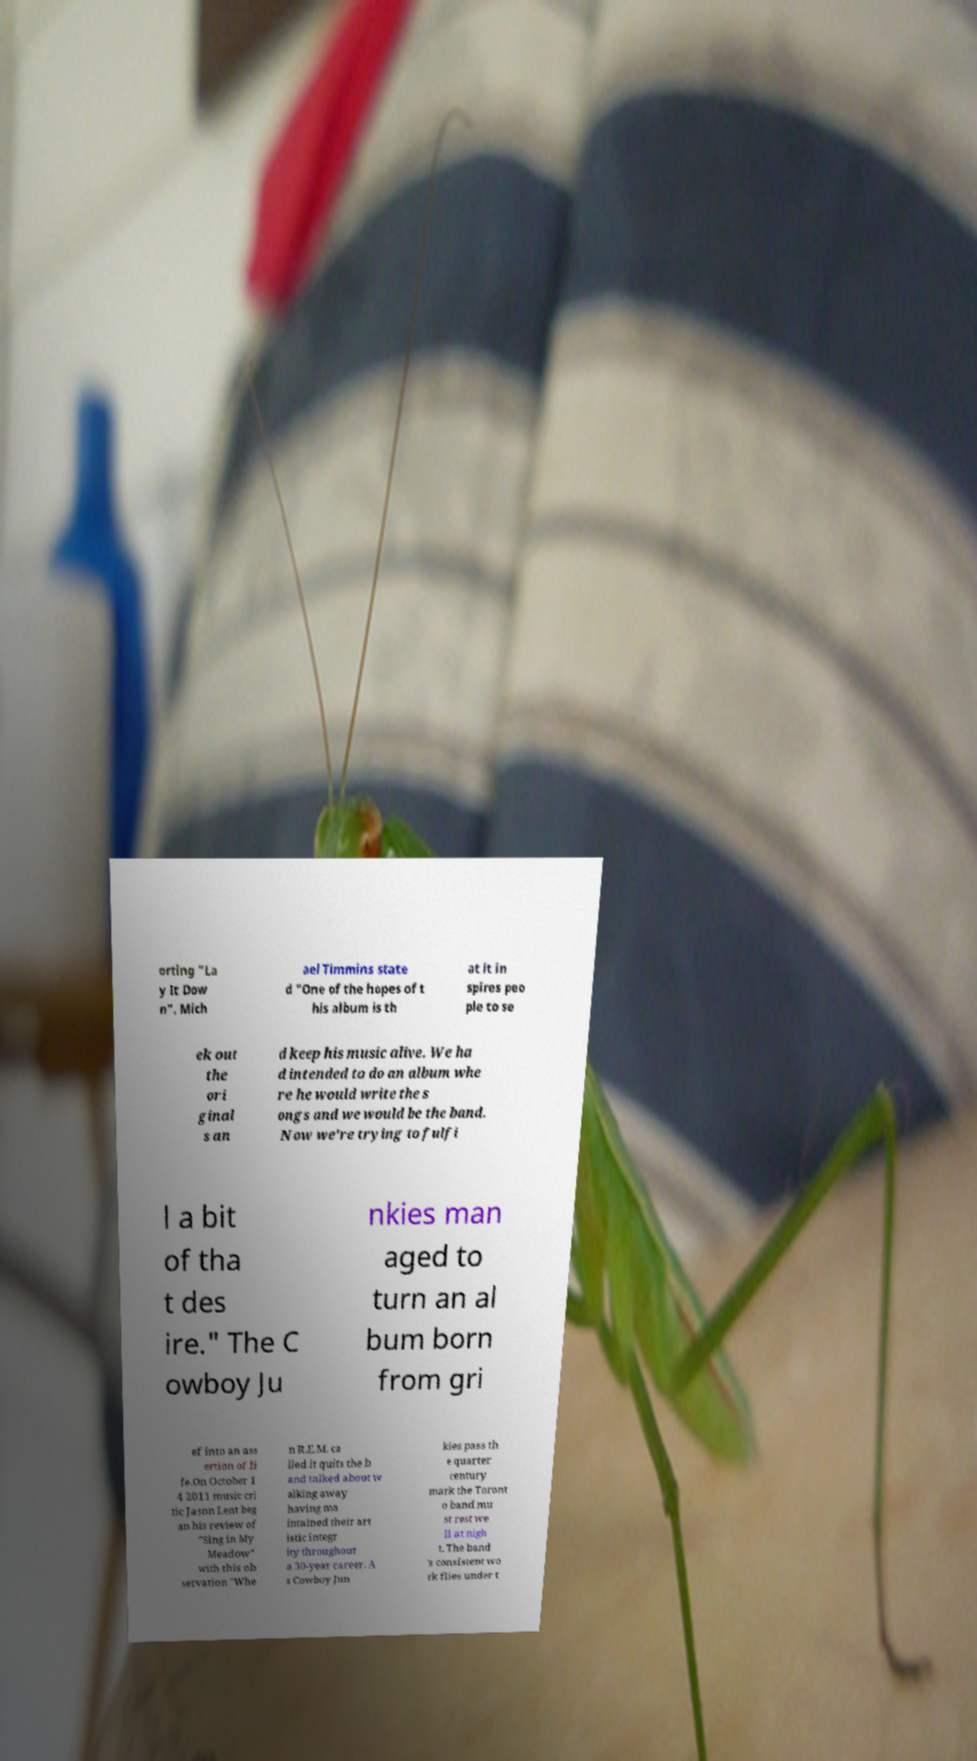Could you assist in decoding the text presented in this image and type it out clearly? orting "La y It Dow n". Mich ael Timmins state d "One of the hopes of t his album is th at it in spires peo ple to se ek out the ori ginal s an d keep his music alive. We ha d intended to do an album whe re he would write the s ongs and we would be the band. Now we're trying to fulfi l a bit of tha t des ire." The C owboy Ju nkies man aged to turn an al bum born from gri ef into an ass ertion of li fe.On October 1 4 2011 music cri tic Jason Lent beg an his review of "Sing in My Meadow" with this ob servation "Whe n R.E.M. ca lled it quits the b and talked about w alking away having ma intained their art istic integr ity throughout a 30-year career. A s Cowboy Jun kies pass th e quarter century mark the Toront o band mu st rest we ll at nigh t. The band 's consistent wo rk flies under t 